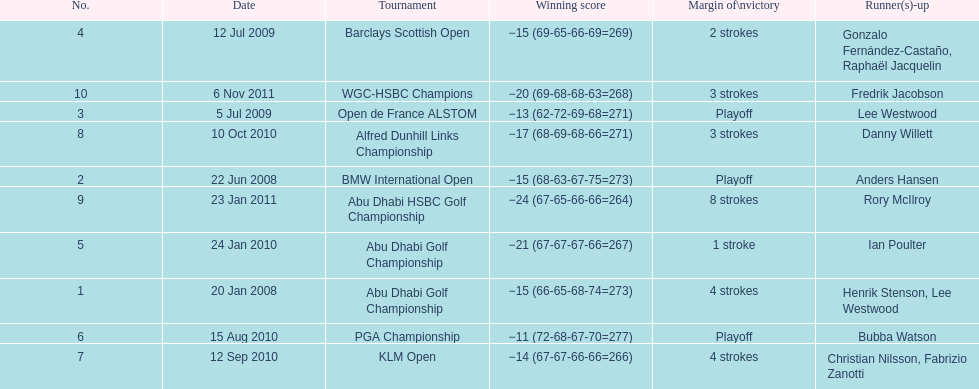How long separated the playoff victory at bmw international open and the 4 stroke victory at the klm open? 2 years. 